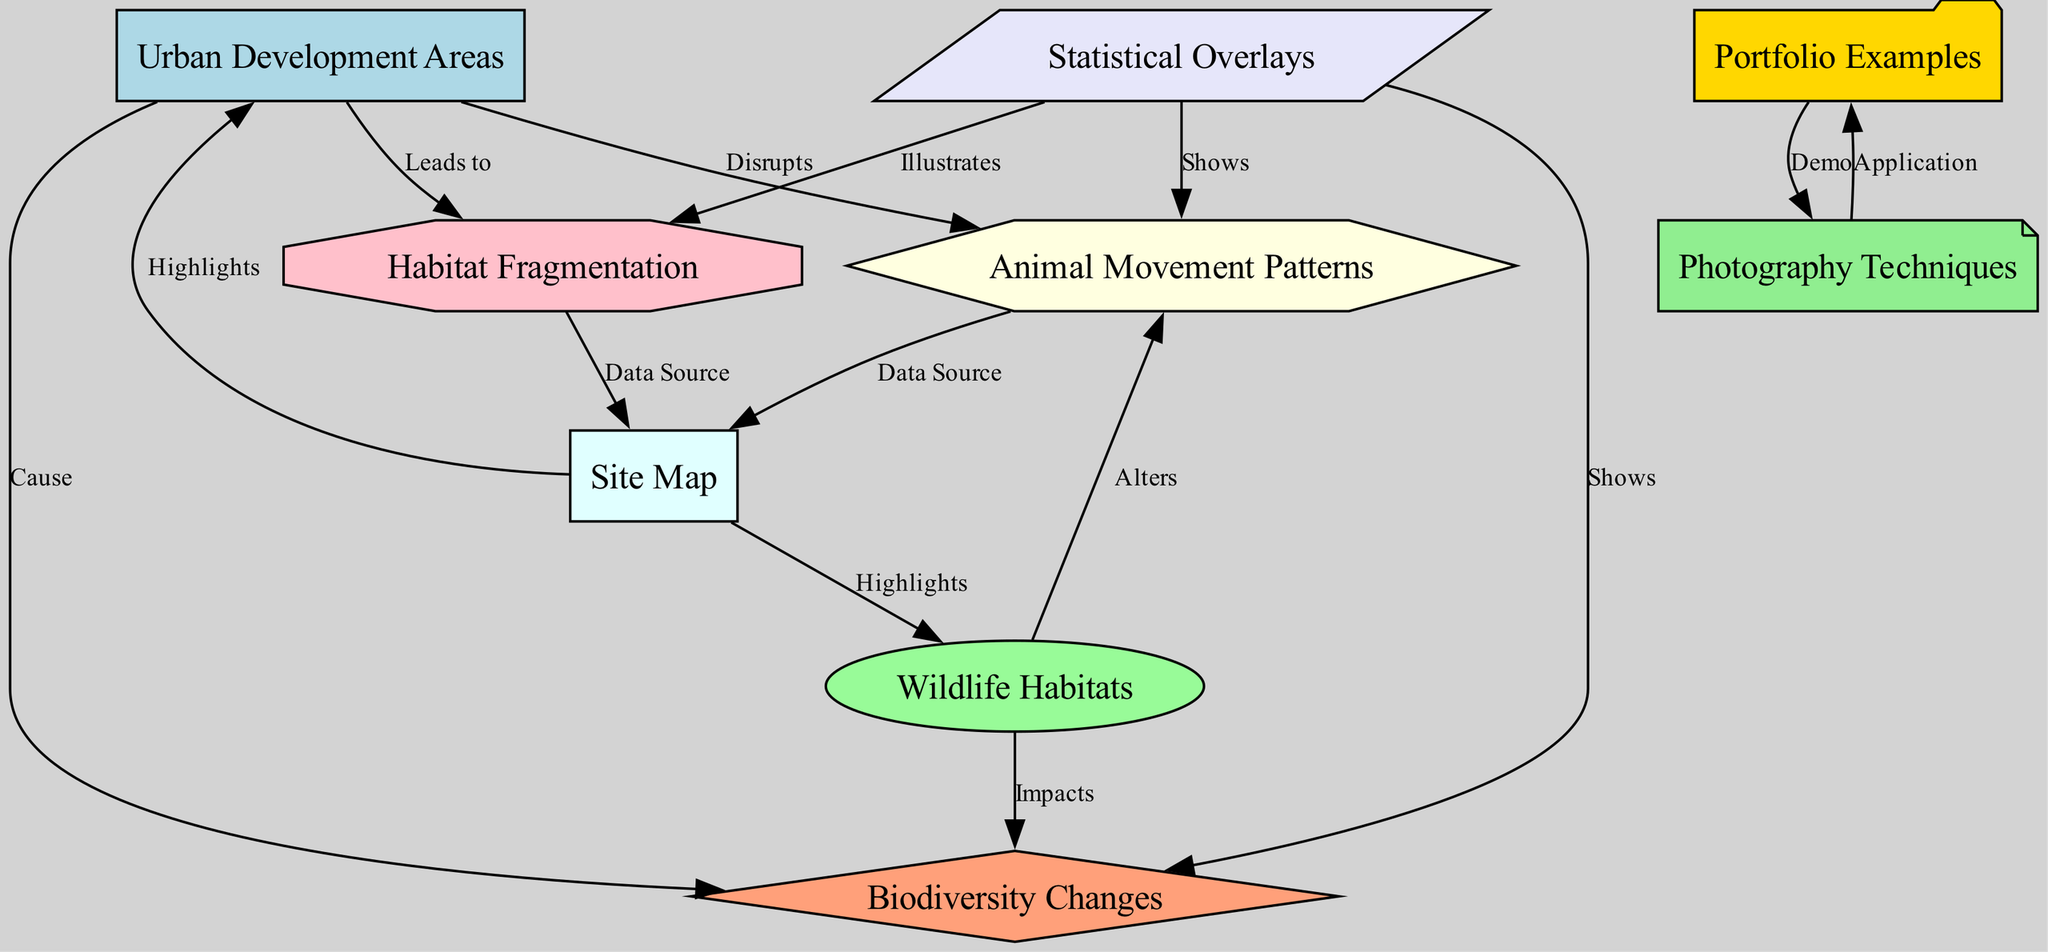What are the different types of nodes in the diagram? The diagram includes nodes labeled as Urban Development Areas, Wildlife Habitats, Biodiversity Changes, Animal Movement Patterns, Habitat Fragmentation, Site Map, Statistical Overlays, Portfolio Examples, and Photography Techniques.
Answer: Urban Development Areas, Wildlife Habitats, Biodiversity Changes, Animal Movement Patterns, Habitat Fragmentation, Site Map, Statistical Overlays, Portfolio Examples, Photography Techniques How many edges are in the diagram? By counting all the connections labeled as cause, disrupts, leads to, impacts, alters, highlights, shows, and illustrates, I find a total of 12 edges connecting various nodes in the diagram.
Answer: 12 What relationship exists between Urban Development Areas and Animal Movement Patterns? The edge from Urban Development Areas to Animal Movement Patterns is labeled as "Disrupts," indicating that urban development negatively affects animal movements.
Answer: Disrupts Which nodes highlight key information in the Site Map? The Site Map highlights both Urban Development Areas and Wildlife Habitats as it connects to these two nodes, emphasizing their visual representation on the map.
Answer: Urban Development Areas, Wildlife Habitats What does the Statistical Overlays node show? The Statistical Overlays node shows both Biodiversity Changes and Animal Movement Patterns, indicating that statistical data assists in understanding these aspects of wildlife.
Answer: Biodiversity Changes, Animal Movement Patterns How does Habitat Fragmentation relate to Urban Development Areas? The edge leads from Urban Development Areas to Habitat Fragmentation labeled "Leads to," showing that urban development contributes directly to the fragmentation of habitats.
Answer: Leads to Which node illustrates the effects on Biodiversity Changes? The edge from Statistical Overlays to Biodiversity Changes, labeled as "Shows," illustrates how statistical overlays provide insights into the impacts on biodiversity due to urban development.
Answer: Shows How does Animal Movement Patterns connect to the Site Map? The connection is labeled "Data Source," indicating that Animal Movement Patterns serve as a data source utilized within the context of the Site Map.
Answer: Data Source What implication does Wildlife Habitats have on Biodiversity Changes? The relationship labeled "Impacts" shows that Wildlife Habitats are important for understanding the elements that affect biodiversity.
Answer: Impacts 